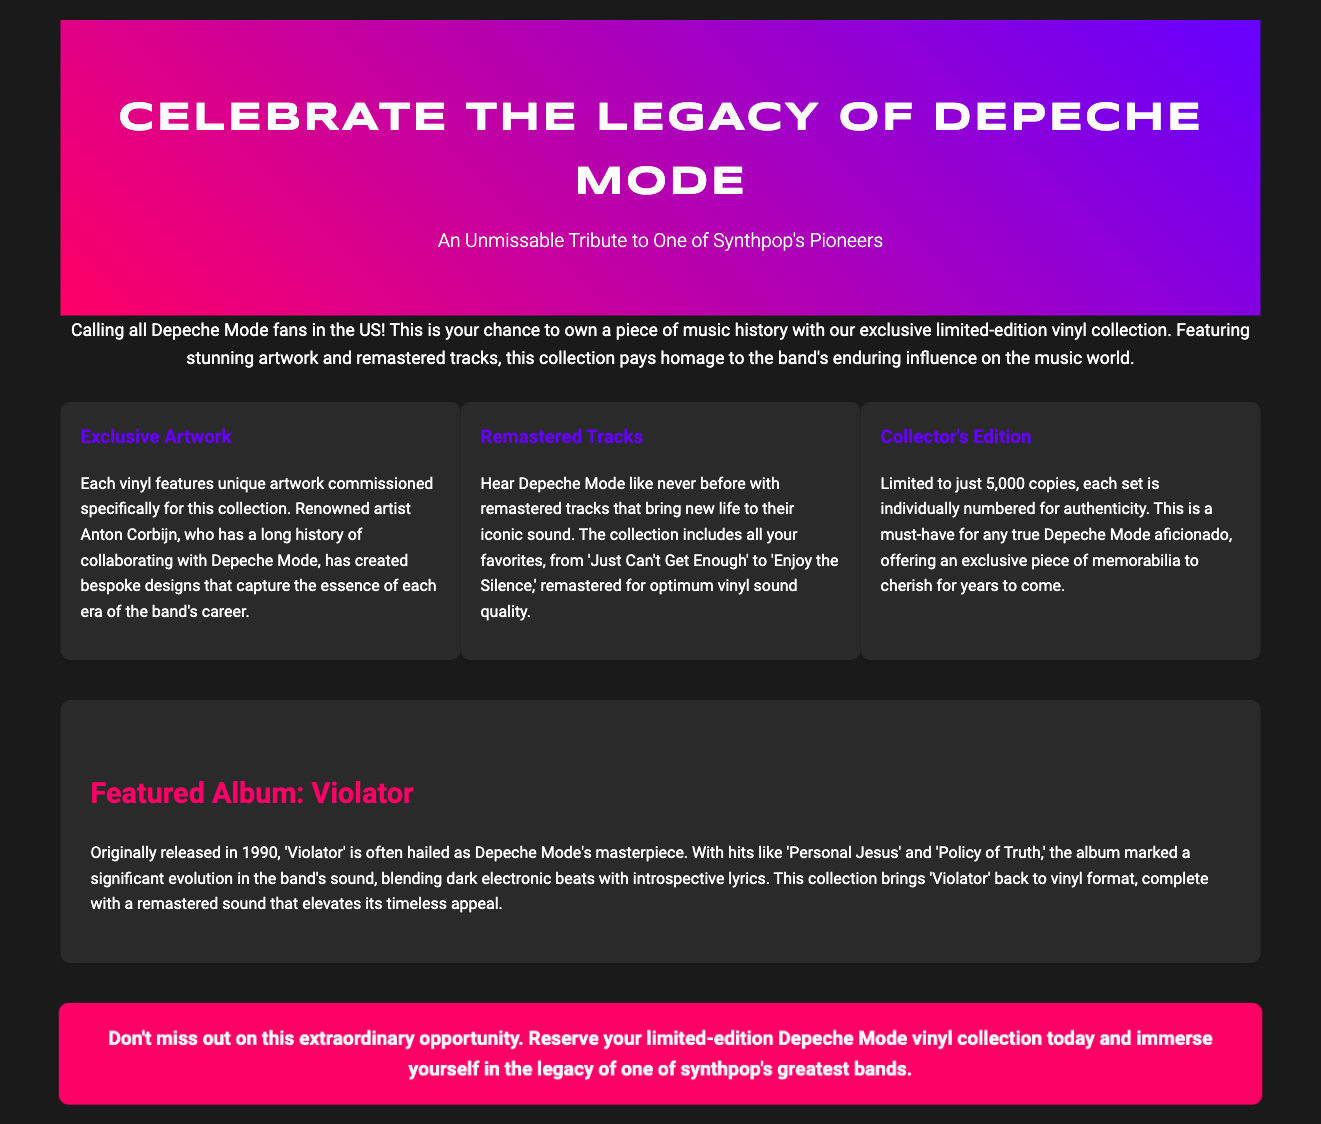What is the title of the limited-edition collection? The title is stated prominently in the document, which is "Depeche Mode Limited-Edition Vinyl Collection."
Answer: Depeche Mode Limited-Edition Vinyl Collection Who created the exclusive artwork for the vinyl collection? The document mentions the renowned artist who created the artwork, which is Anton Corbijn.
Answer: Anton Corbijn How many copies of the collector's edition will be available? The document specifies that the collectors' edition is limited to 5,000 copies.
Answer: 5000 What year was the album 'Violator' originally released? The information is provided in the document, indicating that 'Violator' was released in 1990.
Answer: 1990 What is one of the hit songs from the album 'Violator'? The document enumerates several hit songs, including 'Personal Jesus' as one of them.
Answer: Personal Jesus Which two hits from the collection are mentioned in the remastered tracks feature? The document lists 'Just Can't Get Enough' and 'Enjoy the Silence' as part of the remastered tracks.
Answer: Just Can't Get Enough, Enjoy the Silence What unique feature does each vinyl have? The document states that each vinyl features unique artwork commissioned for the collection, making it distinct.
Answer: Unique artwork What is the main purpose of this advertisement? The document aims to inform and encourage fans to reserve their vinyl collection.
Answer: Reserve your limited-edition Depeche Mode vinyl collection today 